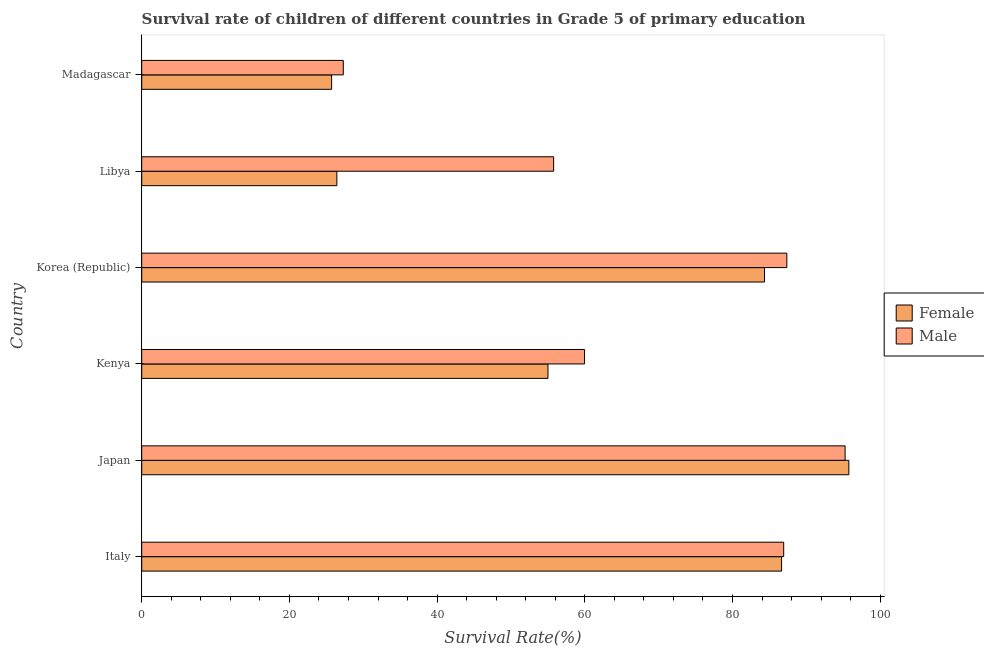How many groups of bars are there?
Your response must be concise. 6. Are the number of bars on each tick of the Y-axis equal?
Offer a terse response. Yes. How many bars are there on the 3rd tick from the top?
Your answer should be compact. 2. What is the label of the 2nd group of bars from the top?
Offer a terse response. Libya. What is the survival rate of female students in primary education in Kenya?
Offer a very short reply. 55.01. Across all countries, what is the maximum survival rate of female students in primary education?
Your answer should be compact. 95.75. Across all countries, what is the minimum survival rate of female students in primary education?
Ensure brevity in your answer.  25.71. In which country was the survival rate of male students in primary education maximum?
Make the answer very short. Japan. In which country was the survival rate of male students in primary education minimum?
Ensure brevity in your answer.  Madagascar. What is the total survival rate of male students in primary education in the graph?
Give a very brief answer. 412.57. What is the difference between the survival rate of male students in primary education in Korea (Republic) and that in Madagascar?
Offer a terse response. 60.06. What is the difference between the survival rate of male students in primary education in Korea (Republic) and the survival rate of female students in primary education in Madagascar?
Provide a succinct answer. 61.64. What is the average survival rate of female students in primary education per country?
Provide a short and direct response. 62.31. What is the difference between the survival rate of female students in primary education and survival rate of male students in primary education in Madagascar?
Offer a very short reply. -1.58. What is the ratio of the survival rate of female students in primary education in Libya to that in Madagascar?
Make the answer very short. 1.03. Is the survival rate of male students in primary education in Japan less than that in Kenya?
Provide a succinct answer. No. What is the difference between the highest and the second highest survival rate of female students in primary education?
Your answer should be very brief. 9.11. What is the difference between the highest and the lowest survival rate of male students in primary education?
Offer a terse response. 67.95. What does the 1st bar from the top in Japan represents?
Give a very brief answer. Male. How many bars are there?
Ensure brevity in your answer.  12. Are all the bars in the graph horizontal?
Your response must be concise. Yes. How many countries are there in the graph?
Keep it short and to the point. 6. What is the difference between two consecutive major ticks on the X-axis?
Your answer should be compact. 20. Are the values on the major ticks of X-axis written in scientific E-notation?
Provide a succinct answer. No. What is the title of the graph?
Your answer should be very brief. Survival rate of children of different countries in Grade 5 of primary education. Does "Primary income" appear as one of the legend labels in the graph?
Provide a short and direct response. No. What is the label or title of the X-axis?
Keep it short and to the point. Survival Rate(%). What is the label or title of the Y-axis?
Your answer should be compact. Country. What is the Survival Rate(%) in Female in Italy?
Your answer should be very brief. 86.64. What is the Survival Rate(%) of Male in Italy?
Make the answer very short. 86.93. What is the Survival Rate(%) of Female in Japan?
Provide a short and direct response. 95.75. What is the Survival Rate(%) in Male in Japan?
Offer a terse response. 95.24. What is the Survival Rate(%) in Female in Kenya?
Make the answer very short. 55.01. What is the Survival Rate(%) in Male in Kenya?
Make the answer very short. 59.96. What is the Survival Rate(%) of Female in Korea (Republic)?
Make the answer very short. 84.33. What is the Survival Rate(%) of Male in Korea (Republic)?
Provide a succinct answer. 87.36. What is the Survival Rate(%) in Female in Libya?
Keep it short and to the point. 26.42. What is the Survival Rate(%) in Male in Libya?
Provide a succinct answer. 55.78. What is the Survival Rate(%) of Female in Madagascar?
Offer a very short reply. 25.71. What is the Survival Rate(%) of Male in Madagascar?
Your answer should be compact. 27.3. Across all countries, what is the maximum Survival Rate(%) in Female?
Ensure brevity in your answer.  95.75. Across all countries, what is the maximum Survival Rate(%) of Male?
Offer a very short reply. 95.24. Across all countries, what is the minimum Survival Rate(%) of Female?
Your response must be concise. 25.71. Across all countries, what is the minimum Survival Rate(%) in Male?
Provide a short and direct response. 27.3. What is the total Survival Rate(%) in Female in the graph?
Offer a terse response. 373.88. What is the total Survival Rate(%) in Male in the graph?
Ensure brevity in your answer.  412.57. What is the difference between the Survival Rate(%) in Female in Italy and that in Japan?
Provide a succinct answer. -9.11. What is the difference between the Survival Rate(%) of Male in Italy and that in Japan?
Offer a terse response. -8.32. What is the difference between the Survival Rate(%) of Female in Italy and that in Kenya?
Offer a terse response. 31.63. What is the difference between the Survival Rate(%) in Male in Italy and that in Kenya?
Your answer should be compact. 26.97. What is the difference between the Survival Rate(%) in Female in Italy and that in Korea (Republic)?
Your answer should be compact. 2.31. What is the difference between the Survival Rate(%) in Male in Italy and that in Korea (Republic)?
Provide a short and direct response. -0.43. What is the difference between the Survival Rate(%) of Female in Italy and that in Libya?
Provide a short and direct response. 60.22. What is the difference between the Survival Rate(%) in Male in Italy and that in Libya?
Your answer should be very brief. 31.15. What is the difference between the Survival Rate(%) of Female in Italy and that in Madagascar?
Provide a short and direct response. 60.93. What is the difference between the Survival Rate(%) of Male in Italy and that in Madagascar?
Keep it short and to the point. 59.63. What is the difference between the Survival Rate(%) in Female in Japan and that in Kenya?
Keep it short and to the point. 40.74. What is the difference between the Survival Rate(%) of Male in Japan and that in Kenya?
Your answer should be very brief. 35.28. What is the difference between the Survival Rate(%) of Female in Japan and that in Korea (Republic)?
Provide a short and direct response. 11.42. What is the difference between the Survival Rate(%) of Male in Japan and that in Korea (Republic)?
Provide a short and direct response. 7.89. What is the difference between the Survival Rate(%) of Female in Japan and that in Libya?
Make the answer very short. 69.33. What is the difference between the Survival Rate(%) in Male in Japan and that in Libya?
Ensure brevity in your answer.  39.47. What is the difference between the Survival Rate(%) in Female in Japan and that in Madagascar?
Provide a succinct answer. 70.04. What is the difference between the Survival Rate(%) in Male in Japan and that in Madagascar?
Ensure brevity in your answer.  67.95. What is the difference between the Survival Rate(%) of Female in Kenya and that in Korea (Republic)?
Your answer should be compact. -29.32. What is the difference between the Survival Rate(%) in Male in Kenya and that in Korea (Republic)?
Offer a very short reply. -27.39. What is the difference between the Survival Rate(%) in Female in Kenya and that in Libya?
Offer a very short reply. 28.59. What is the difference between the Survival Rate(%) of Male in Kenya and that in Libya?
Offer a terse response. 4.19. What is the difference between the Survival Rate(%) of Female in Kenya and that in Madagascar?
Make the answer very short. 29.3. What is the difference between the Survival Rate(%) of Male in Kenya and that in Madagascar?
Provide a short and direct response. 32.67. What is the difference between the Survival Rate(%) in Female in Korea (Republic) and that in Libya?
Keep it short and to the point. 57.91. What is the difference between the Survival Rate(%) in Male in Korea (Republic) and that in Libya?
Make the answer very short. 31.58. What is the difference between the Survival Rate(%) of Female in Korea (Republic) and that in Madagascar?
Make the answer very short. 58.62. What is the difference between the Survival Rate(%) of Male in Korea (Republic) and that in Madagascar?
Your answer should be very brief. 60.06. What is the difference between the Survival Rate(%) in Female in Libya and that in Madagascar?
Offer a terse response. 0.71. What is the difference between the Survival Rate(%) in Male in Libya and that in Madagascar?
Give a very brief answer. 28.48. What is the difference between the Survival Rate(%) of Female in Italy and the Survival Rate(%) of Male in Japan?
Your response must be concise. -8.6. What is the difference between the Survival Rate(%) of Female in Italy and the Survival Rate(%) of Male in Kenya?
Provide a succinct answer. 26.68. What is the difference between the Survival Rate(%) in Female in Italy and the Survival Rate(%) in Male in Korea (Republic)?
Your response must be concise. -0.71. What is the difference between the Survival Rate(%) of Female in Italy and the Survival Rate(%) of Male in Libya?
Offer a terse response. 30.87. What is the difference between the Survival Rate(%) of Female in Italy and the Survival Rate(%) of Male in Madagascar?
Offer a very short reply. 59.35. What is the difference between the Survival Rate(%) of Female in Japan and the Survival Rate(%) of Male in Kenya?
Make the answer very short. 35.79. What is the difference between the Survival Rate(%) in Female in Japan and the Survival Rate(%) in Male in Korea (Republic)?
Make the answer very short. 8.4. What is the difference between the Survival Rate(%) of Female in Japan and the Survival Rate(%) of Male in Libya?
Make the answer very short. 39.97. What is the difference between the Survival Rate(%) in Female in Japan and the Survival Rate(%) in Male in Madagascar?
Your response must be concise. 68.46. What is the difference between the Survival Rate(%) in Female in Kenya and the Survival Rate(%) in Male in Korea (Republic)?
Keep it short and to the point. -32.34. What is the difference between the Survival Rate(%) in Female in Kenya and the Survival Rate(%) in Male in Libya?
Keep it short and to the point. -0.77. What is the difference between the Survival Rate(%) of Female in Kenya and the Survival Rate(%) of Male in Madagascar?
Your answer should be compact. 27.72. What is the difference between the Survival Rate(%) in Female in Korea (Republic) and the Survival Rate(%) in Male in Libya?
Your answer should be compact. 28.56. What is the difference between the Survival Rate(%) of Female in Korea (Republic) and the Survival Rate(%) of Male in Madagascar?
Offer a very short reply. 57.04. What is the difference between the Survival Rate(%) of Female in Libya and the Survival Rate(%) of Male in Madagascar?
Ensure brevity in your answer.  -0.87. What is the average Survival Rate(%) of Female per country?
Give a very brief answer. 62.31. What is the average Survival Rate(%) of Male per country?
Your answer should be very brief. 68.76. What is the difference between the Survival Rate(%) in Female and Survival Rate(%) in Male in Italy?
Make the answer very short. -0.29. What is the difference between the Survival Rate(%) in Female and Survival Rate(%) in Male in Japan?
Keep it short and to the point. 0.51. What is the difference between the Survival Rate(%) of Female and Survival Rate(%) of Male in Kenya?
Your answer should be compact. -4.95. What is the difference between the Survival Rate(%) in Female and Survival Rate(%) in Male in Korea (Republic)?
Make the answer very short. -3.02. What is the difference between the Survival Rate(%) in Female and Survival Rate(%) in Male in Libya?
Make the answer very short. -29.35. What is the difference between the Survival Rate(%) of Female and Survival Rate(%) of Male in Madagascar?
Offer a very short reply. -1.58. What is the ratio of the Survival Rate(%) in Female in Italy to that in Japan?
Offer a terse response. 0.9. What is the ratio of the Survival Rate(%) in Male in Italy to that in Japan?
Your answer should be compact. 0.91. What is the ratio of the Survival Rate(%) of Female in Italy to that in Kenya?
Offer a terse response. 1.57. What is the ratio of the Survival Rate(%) in Male in Italy to that in Kenya?
Make the answer very short. 1.45. What is the ratio of the Survival Rate(%) in Female in Italy to that in Korea (Republic)?
Offer a terse response. 1.03. What is the ratio of the Survival Rate(%) in Male in Italy to that in Korea (Republic)?
Provide a short and direct response. 1. What is the ratio of the Survival Rate(%) of Female in Italy to that in Libya?
Your answer should be compact. 3.28. What is the ratio of the Survival Rate(%) of Male in Italy to that in Libya?
Your response must be concise. 1.56. What is the ratio of the Survival Rate(%) of Female in Italy to that in Madagascar?
Give a very brief answer. 3.37. What is the ratio of the Survival Rate(%) of Male in Italy to that in Madagascar?
Provide a succinct answer. 3.18. What is the ratio of the Survival Rate(%) of Female in Japan to that in Kenya?
Keep it short and to the point. 1.74. What is the ratio of the Survival Rate(%) in Male in Japan to that in Kenya?
Your response must be concise. 1.59. What is the ratio of the Survival Rate(%) of Female in Japan to that in Korea (Republic)?
Make the answer very short. 1.14. What is the ratio of the Survival Rate(%) in Male in Japan to that in Korea (Republic)?
Offer a very short reply. 1.09. What is the ratio of the Survival Rate(%) in Female in Japan to that in Libya?
Give a very brief answer. 3.62. What is the ratio of the Survival Rate(%) of Male in Japan to that in Libya?
Your answer should be very brief. 1.71. What is the ratio of the Survival Rate(%) of Female in Japan to that in Madagascar?
Your answer should be compact. 3.72. What is the ratio of the Survival Rate(%) in Male in Japan to that in Madagascar?
Keep it short and to the point. 3.49. What is the ratio of the Survival Rate(%) of Female in Kenya to that in Korea (Republic)?
Your answer should be very brief. 0.65. What is the ratio of the Survival Rate(%) of Male in Kenya to that in Korea (Republic)?
Your response must be concise. 0.69. What is the ratio of the Survival Rate(%) of Female in Kenya to that in Libya?
Offer a terse response. 2.08. What is the ratio of the Survival Rate(%) of Male in Kenya to that in Libya?
Keep it short and to the point. 1.07. What is the ratio of the Survival Rate(%) in Female in Kenya to that in Madagascar?
Offer a very short reply. 2.14. What is the ratio of the Survival Rate(%) of Male in Kenya to that in Madagascar?
Provide a succinct answer. 2.2. What is the ratio of the Survival Rate(%) in Female in Korea (Republic) to that in Libya?
Your answer should be very brief. 3.19. What is the ratio of the Survival Rate(%) of Male in Korea (Republic) to that in Libya?
Keep it short and to the point. 1.57. What is the ratio of the Survival Rate(%) of Female in Korea (Republic) to that in Madagascar?
Provide a short and direct response. 3.28. What is the ratio of the Survival Rate(%) of Male in Korea (Republic) to that in Madagascar?
Offer a terse response. 3.2. What is the ratio of the Survival Rate(%) in Female in Libya to that in Madagascar?
Make the answer very short. 1.03. What is the ratio of the Survival Rate(%) in Male in Libya to that in Madagascar?
Provide a short and direct response. 2.04. What is the difference between the highest and the second highest Survival Rate(%) of Female?
Provide a succinct answer. 9.11. What is the difference between the highest and the second highest Survival Rate(%) of Male?
Your answer should be compact. 7.89. What is the difference between the highest and the lowest Survival Rate(%) in Female?
Ensure brevity in your answer.  70.04. What is the difference between the highest and the lowest Survival Rate(%) in Male?
Provide a succinct answer. 67.95. 